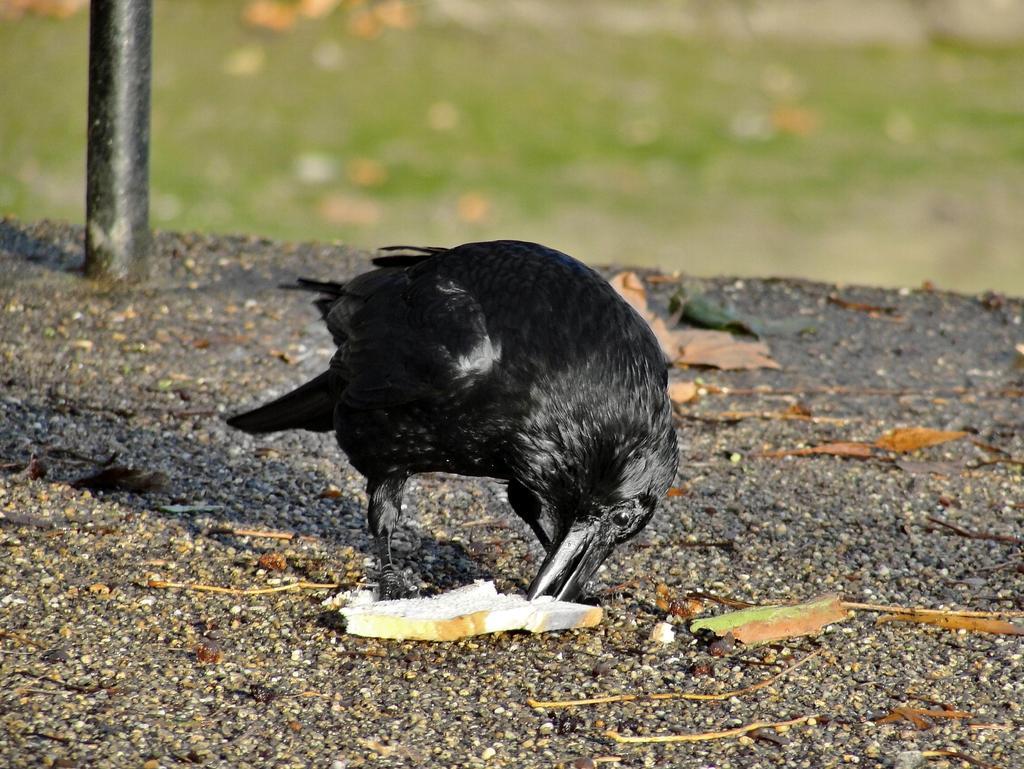In one or two sentences, can you explain what this image depicts? In this image we can see a bird and pole. Background it is blur. 